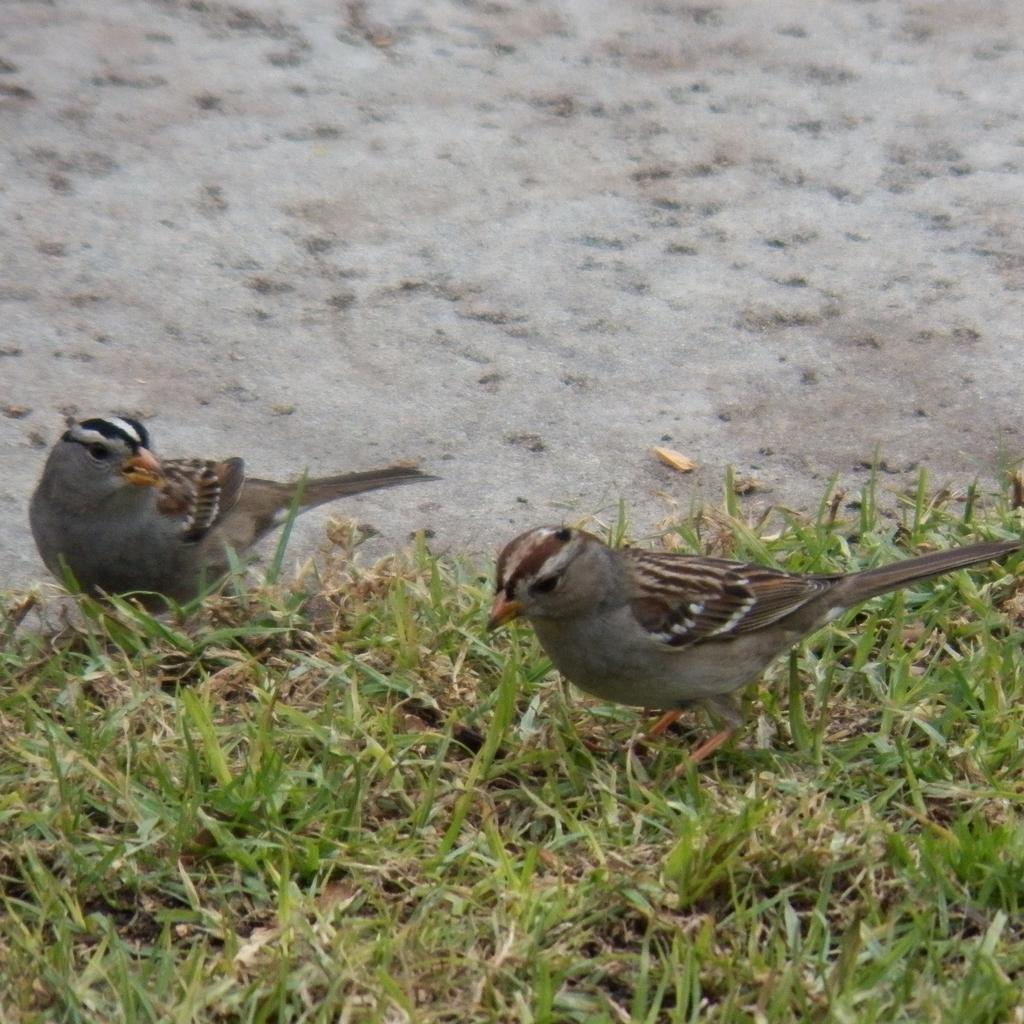How many birds are present in the image? There are two birds in the image. Where are the birds located? The birds are on the grass. What type of meal are the birds preparing in the image? There is no indication in the image that the birds are preparing a meal, as they are simply standing on the grass. 